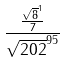<formula> <loc_0><loc_0><loc_500><loc_500>\frac { \frac { \sqrt { 8 } ^ { 1 } } { 7 } } { \sqrt { 2 0 2 } ^ { 9 5 } }</formula> 